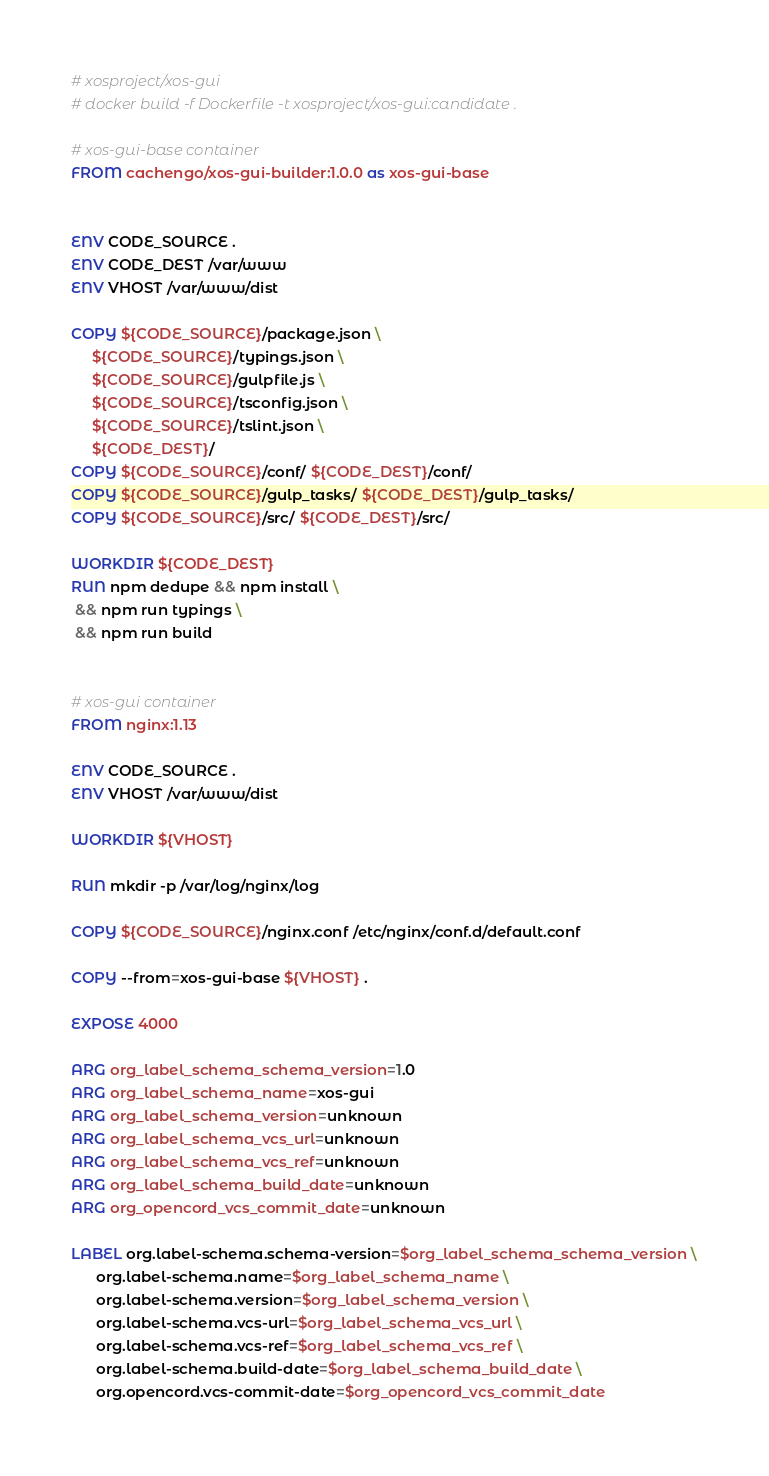<code> <loc_0><loc_0><loc_500><loc_500><_Dockerfile_># xosproject/xos-gui
# docker build -f Dockerfile -t xosproject/xos-gui:candidate .

# xos-gui-base container
FROM cachengo/xos-gui-builder:1.0.0 as xos-gui-base


ENV CODE_SOURCE .
ENV CODE_DEST /var/www
ENV VHOST /var/www/dist

COPY ${CODE_SOURCE}/package.json \
     ${CODE_SOURCE}/typings.json \
     ${CODE_SOURCE}/gulpfile.js \
     ${CODE_SOURCE}/tsconfig.json \
     ${CODE_SOURCE}/tslint.json \
     ${CODE_DEST}/
COPY ${CODE_SOURCE}/conf/ ${CODE_DEST}/conf/
COPY ${CODE_SOURCE}/gulp_tasks/ ${CODE_DEST}/gulp_tasks/
COPY ${CODE_SOURCE}/src/ ${CODE_DEST}/src/

WORKDIR ${CODE_DEST}
RUN npm dedupe && npm install \
 && npm run typings \
 && npm run build


# xos-gui container
FROM nginx:1.13

ENV CODE_SOURCE .
ENV VHOST /var/www/dist

WORKDIR ${VHOST}

RUN mkdir -p /var/log/nginx/log

COPY ${CODE_SOURCE}/nginx.conf /etc/nginx/conf.d/default.conf

COPY --from=xos-gui-base ${VHOST} .

EXPOSE 4000

ARG org_label_schema_schema_version=1.0
ARG org_label_schema_name=xos-gui
ARG org_label_schema_version=unknown
ARG org_label_schema_vcs_url=unknown
ARG org_label_schema_vcs_ref=unknown
ARG org_label_schema_build_date=unknown
ARG org_opencord_vcs_commit_date=unknown

LABEL org.label-schema.schema-version=$org_label_schema_schema_version \
      org.label-schema.name=$org_label_schema_name \
      org.label-schema.version=$org_label_schema_version \
      org.label-schema.vcs-url=$org_label_schema_vcs_url \
      org.label-schema.vcs-ref=$org_label_schema_vcs_ref \
      org.label-schema.build-date=$org_label_schema_build_date \
      org.opencord.vcs-commit-date=$org_opencord_vcs_commit_date
</code> 